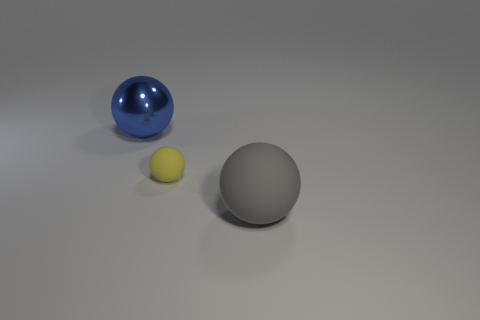What is the shape of the thing that is both behind the gray object and in front of the shiny thing?
Your response must be concise. Sphere. Are there any big blue spheres made of the same material as the tiny yellow object?
Your answer should be compact. No. There is a large ball that is on the right side of the small thing; what color is it?
Offer a very short reply. Gray. Does the large blue metallic object have the same shape as the large object that is in front of the large shiny sphere?
Provide a succinct answer. Yes. Is there another metal sphere that has the same color as the tiny sphere?
Ensure brevity in your answer.  No. There is a gray sphere that is the same material as the yellow thing; what size is it?
Ensure brevity in your answer.  Large. Do the tiny matte thing and the metallic thing have the same color?
Provide a short and direct response. No. Is the shape of the big object that is behind the yellow object the same as  the yellow rubber thing?
Keep it short and to the point. Yes. What number of other spheres are the same size as the shiny sphere?
Give a very brief answer. 1. Is there a large gray matte thing to the left of the rubber sphere that is on the left side of the gray matte sphere?
Provide a succinct answer. No. 